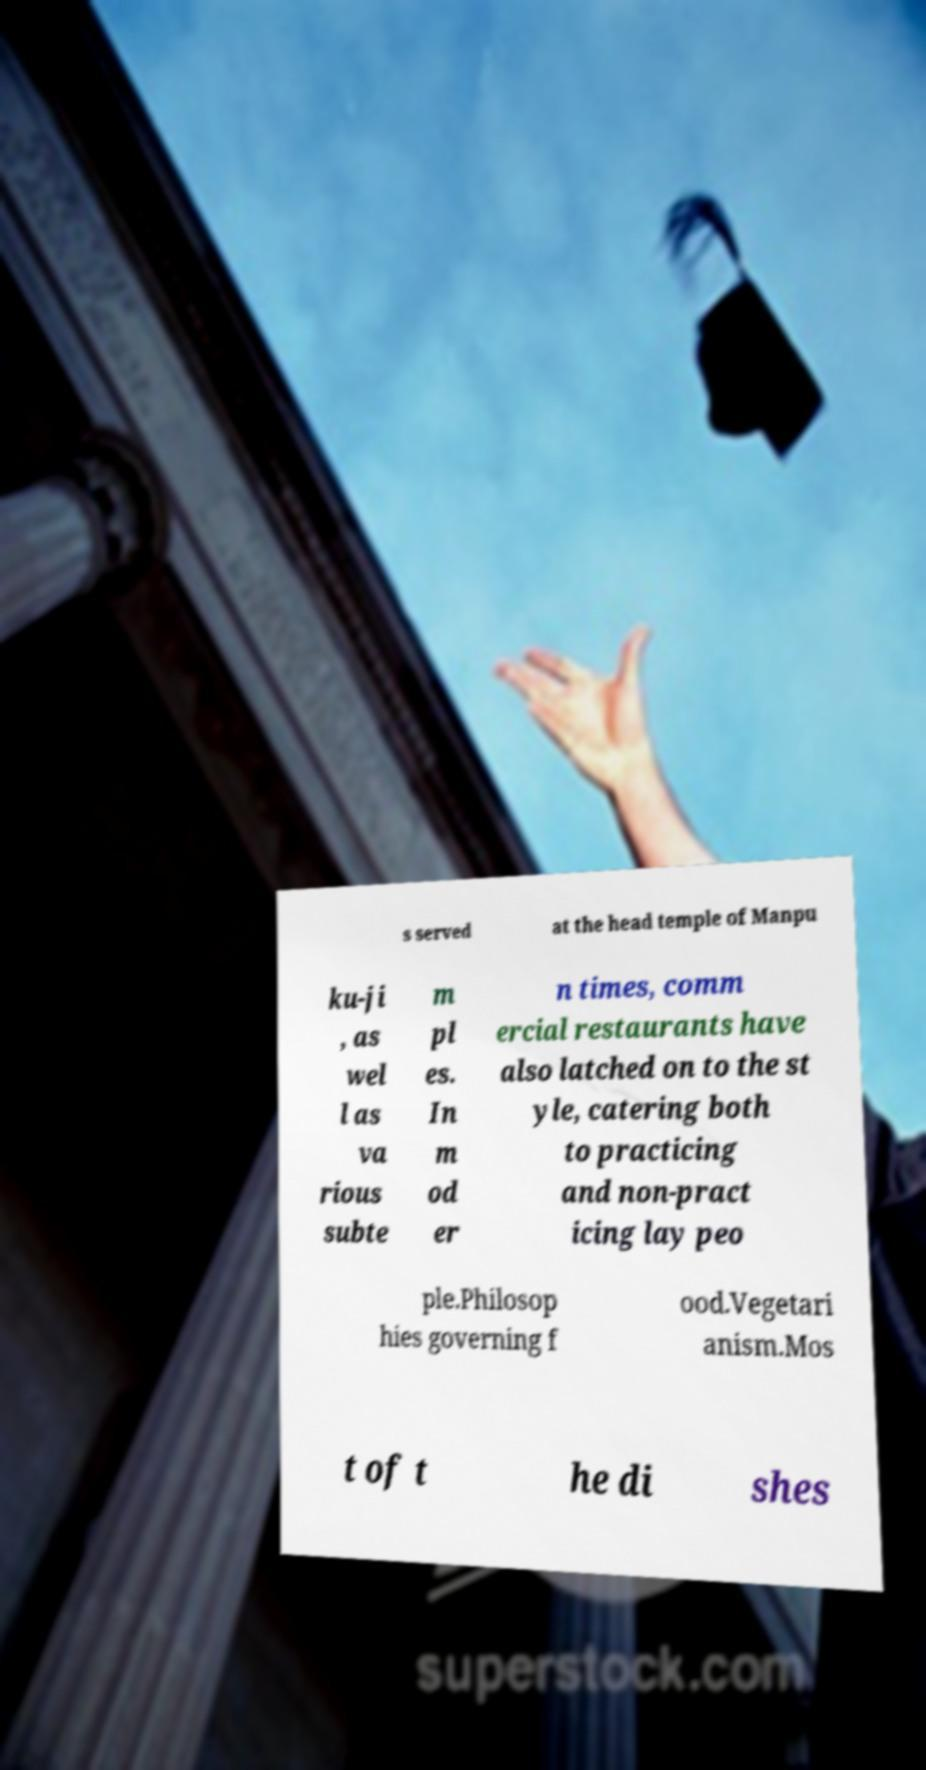Can you read and provide the text displayed in the image?This photo seems to have some interesting text. Can you extract and type it out for me? s served at the head temple of Manpu ku-ji , as wel l as va rious subte m pl es. In m od er n times, comm ercial restaurants have also latched on to the st yle, catering both to practicing and non-pract icing lay peo ple.Philosop hies governing f ood.Vegetari anism.Mos t of t he di shes 